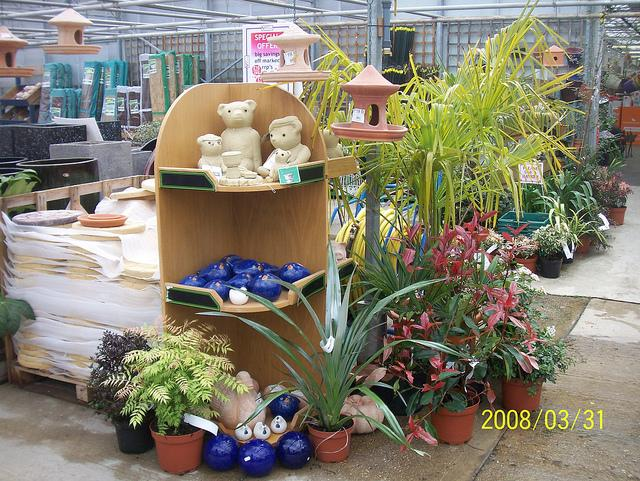What kind of animal is on the top shelf?

Choices:
A) mouse
B) ant
C) bear
D) cat bear 